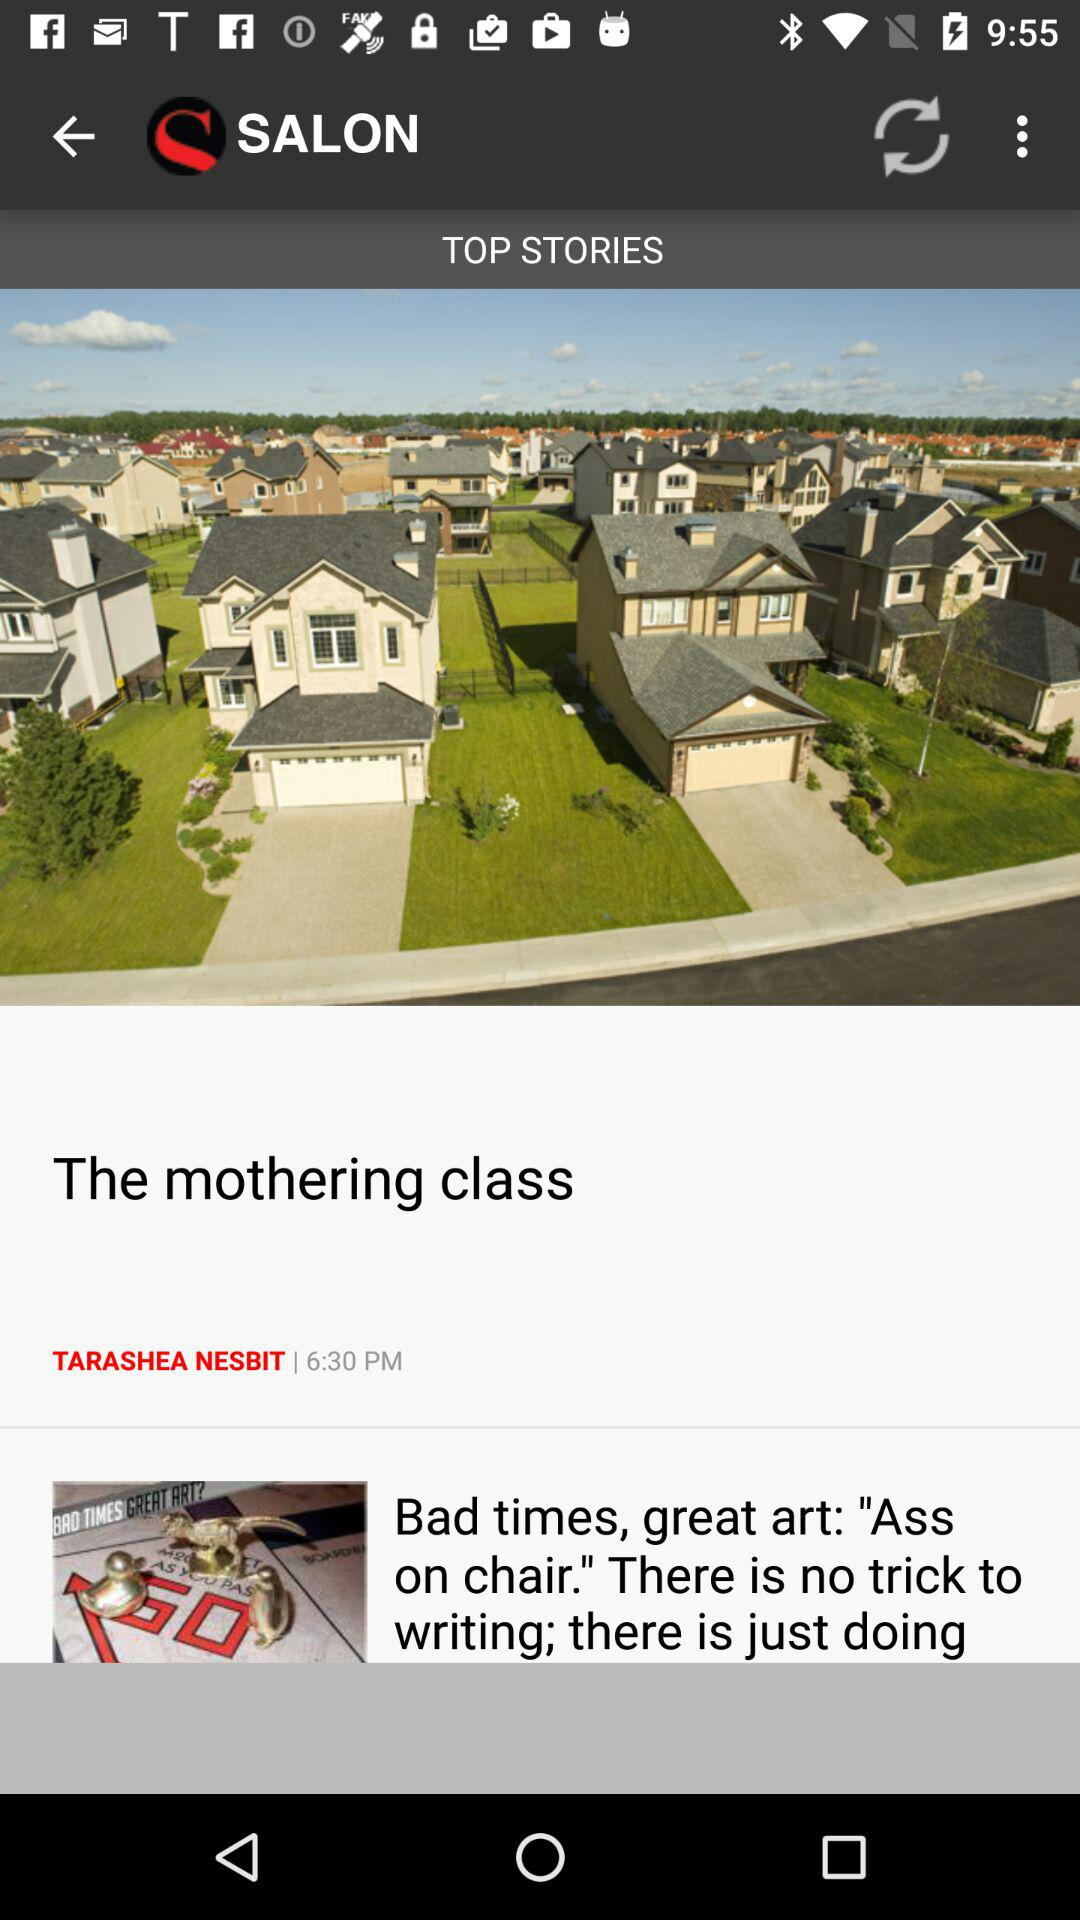What time is shown? The shown time is 6:30 p.m. 